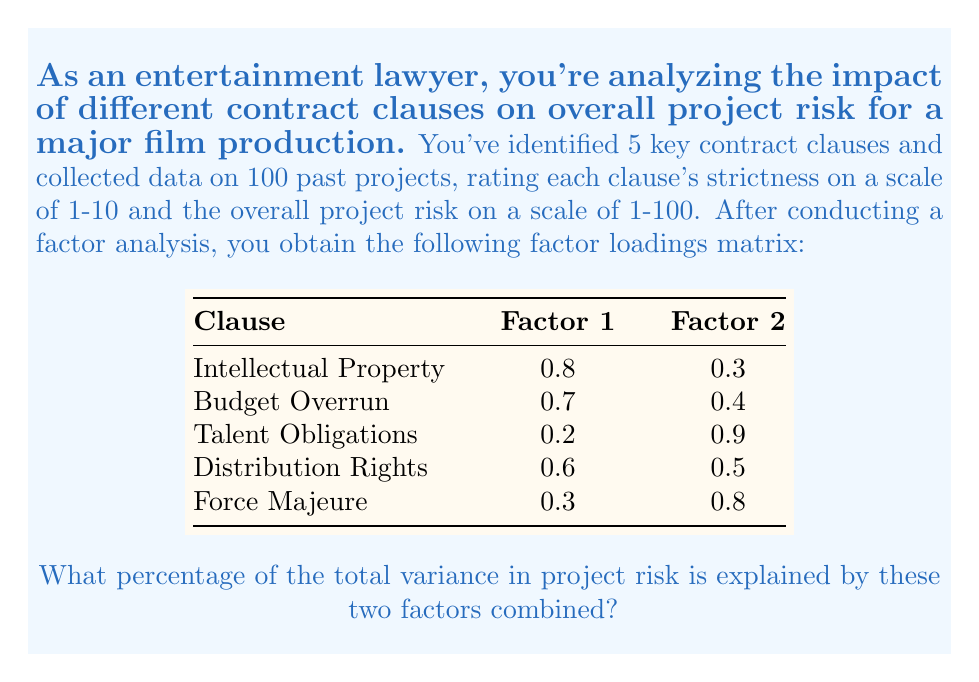Give your solution to this math problem. To solve this problem, we need to follow these steps:

1) In factor analysis, the proportion of variance explained by each factor is equal to the sum of squared factor loadings for that factor, divided by the number of variables.

2) For Factor 1:
   $$(0.8^2 + 0.7^2 + 0.2^2 + 0.6^2 + 0.3^2) / 5 = (0.64 + 0.49 + 0.04 + 0.36 + 0.09) / 5 = 1.62 / 5 = 0.324$$

3) For Factor 2:
   $$(0.3^2 + 0.4^2 + 0.9^2 + 0.5^2 + 0.8^2) / 5 = (0.09 + 0.16 + 0.81 + 0.25 + 0.64) / 5 = 1.95 / 5 = 0.39$$

4) The total proportion of variance explained by both factors is the sum of these two values:
   $$0.324 + 0.39 = 0.714$$

5) To express this as a percentage, we multiply by 100:
   $$0.714 * 100 = 71.4\%$$

Therefore, these two factors combined explain 71.4% of the total variance in project risk.
Answer: 71.4% 